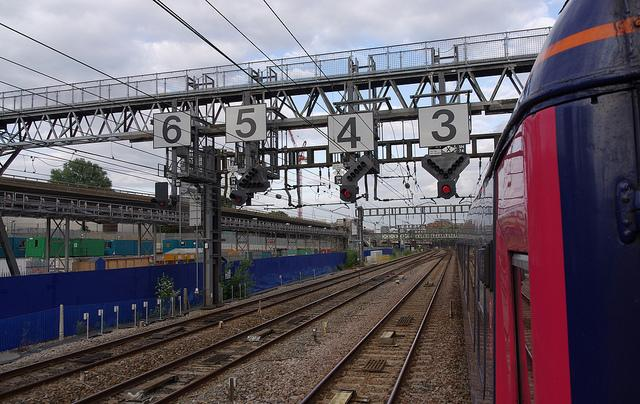What is the next number in the sequence? Please explain your reasoning. two. The number is the next number in the list. 